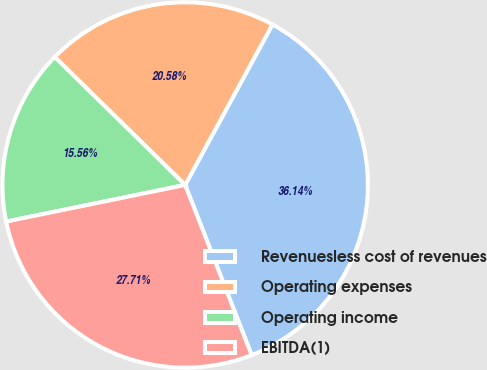Convert chart. <chart><loc_0><loc_0><loc_500><loc_500><pie_chart><fcel>Revenuesless cost of revenues<fcel>Operating expenses<fcel>Operating income<fcel>EBITDA(1)<nl><fcel>36.14%<fcel>20.58%<fcel>15.56%<fcel>27.71%<nl></chart> 